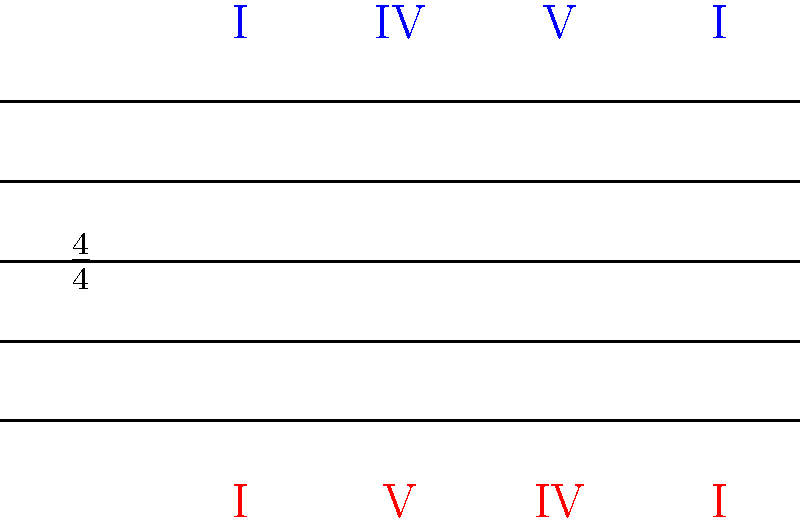Which of the two chord progressions shown in the musical notation above is most commonly associated with the 12-bar blues structure popularized by British Blues musicians like Mick Abrahams? To answer this question, we need to analyze the two chord progressions presented in the musical notation:

1. The blue progression (top): I - IV - V - I
2. The red progression (bottom): I - V - IV - I

Step 1: Recognize the 12-bar blues structure.
The 12-bar blues typically follows a I - IV - V pattern, but stretched over 12 bars.

Step 2: Analyze the blue progression.
The blue progression (I - IV - V - I) closely resembles the basic structure of the 12-bar blues, but condensed.

Step 3: Analyze the red progression.
The red progression (I - V - IV - I) is a common chord progression but doesn't follow the typical 12-bar blues structure.

Step 4: Consider British Blues influence.
British Blues musicians, including Mick Abrahams, often adhered closely to traditional blues structures, including the 12-bar blues.

Step 5: Compare and conclude.
The blue progression (I - IV - V - I) is more closely aligned with the 12-bar blues structure and is therefore more commonly associated with the British Blues style.
Answer: Blue progression (I - IV - V - I) 